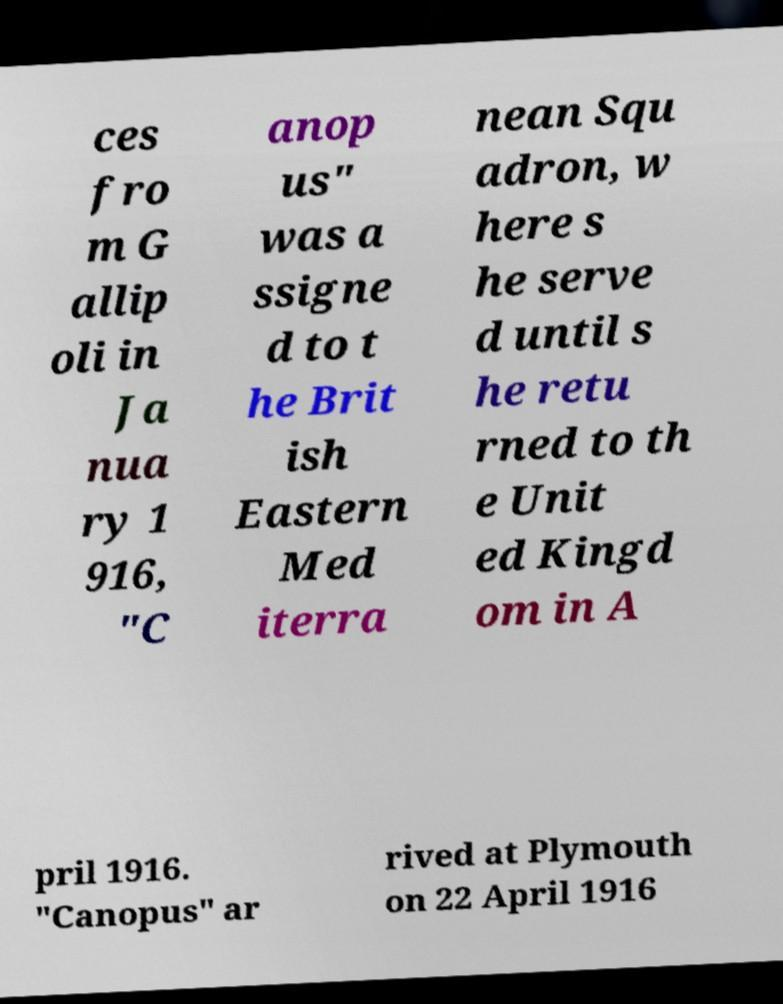Please read and relay the text visible in this image. What does it say? ces fro m G allip oli in Ja nua ry 1 916, "C anop us" was a ssigne d to t he Brit ish Eastern Med iterra nean Squ adron, w here s he serve d until s he retu rned to th e Unit ed Kingd om in A pril 1916. "Canopus" ar rived at Plymouth on 22 April 1916 